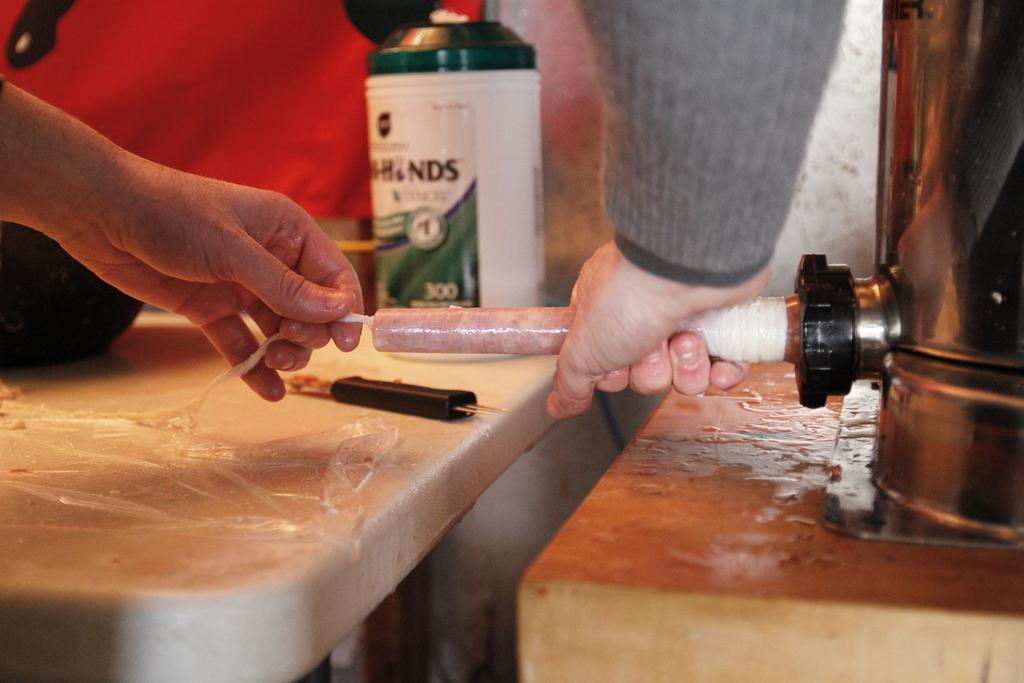How many wipes come in the container?
Offer a terse response. 300. What letters are written on the wipes container?
Make the answer very short. Hinds. 